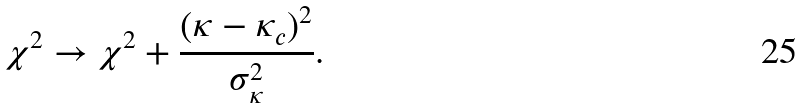<formula> <loc_0><loc_0><loc_500><loc_500>\chi ^ { 2 } \rightarrow \chi ^ { 2 } + \frac { ( \kappa - \kappa _ { c } ) ^ { 2 } } { \sigma _ { \kappa } ^ { 2 } } .</formula> 